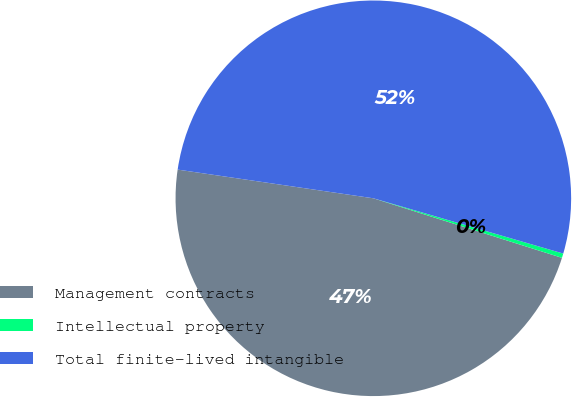Convert chart to OTSL. <chart><loc_0><loc_0><loc_500><loc_500><pie_chart><fcel>Management contracts<fcel>Intellectual property<fcel>Total finite-lived intangible<nl><fcel>47.45%<fcel>0.36%<fcel>52.19%<nl></chart> 